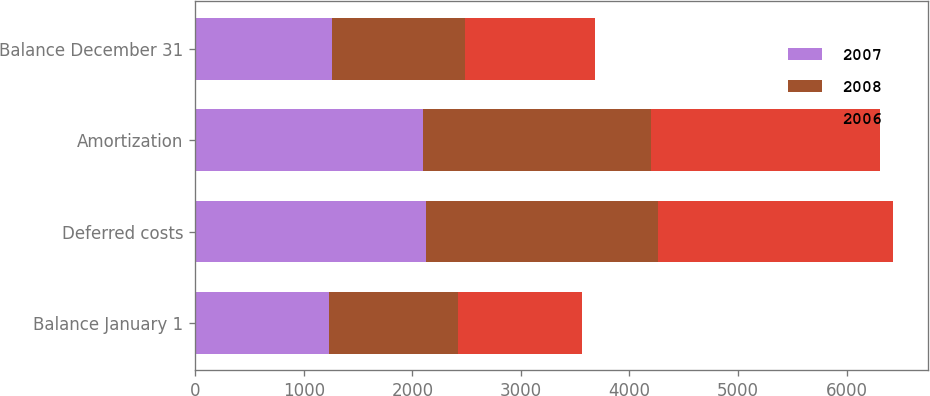Convert chart. <chart><loc_0><loc_0><loc_500><loc_500><stacked_bar_chart><ecel><fcel>Balance January 1<fcel>Deferred costs<fcel>Amortization<fcel>Balance December 31<nl><fcel>2007<fcel>1228<fcel>2127<fcel>2095<fcel>1260<nl><fcel>2008<fcel>1197<fcel>2135<fcel>2104<fcel>1228<nl><fcel>2006<fcel>1134<fcel>2169<fcel>2106<fcel>1197<nl></chart> 